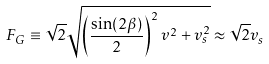Convert formula to latex. <formula><loc_0><loc_0><loc_500><loc_500>F _ { G } \equiv \sqrt { 2 } \sqrt { \left ( \frac { \sin ( 2 \beta ) } { 2 } \right ) ^ { 2 } v ^ { 2 } + v _ { s } ^ { 2 } } \approx \sqrt { 2 } v _ { s }</formula> 